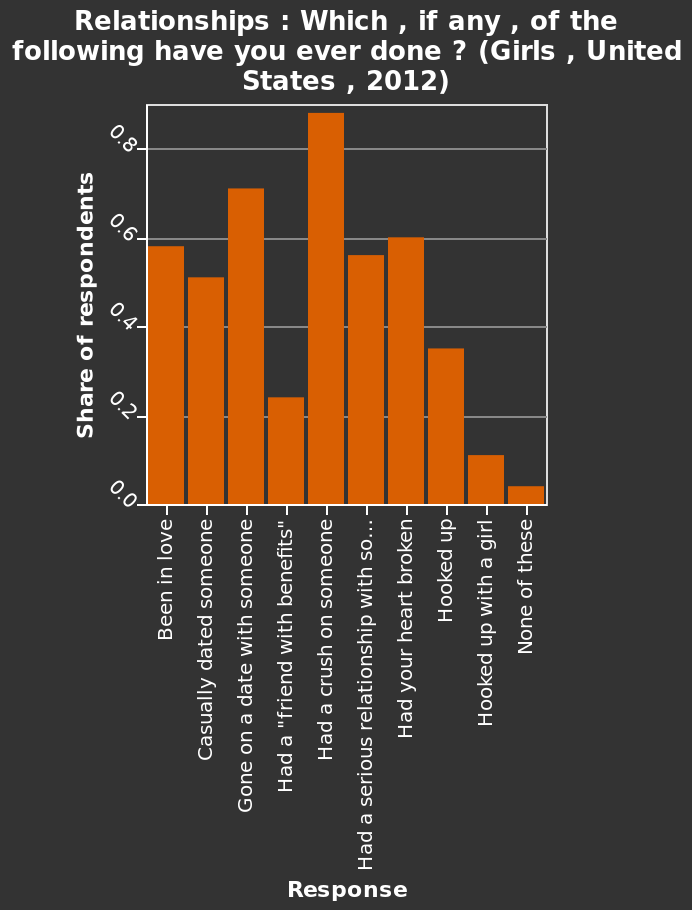<image>
What is shown on the y-axis of the bar graph?  The y-axis of the bar graph shows the Share of respondents. What is the range of values represented on the y-axis?  The range of values on the y-axis is from 0.0 to 0.8. 